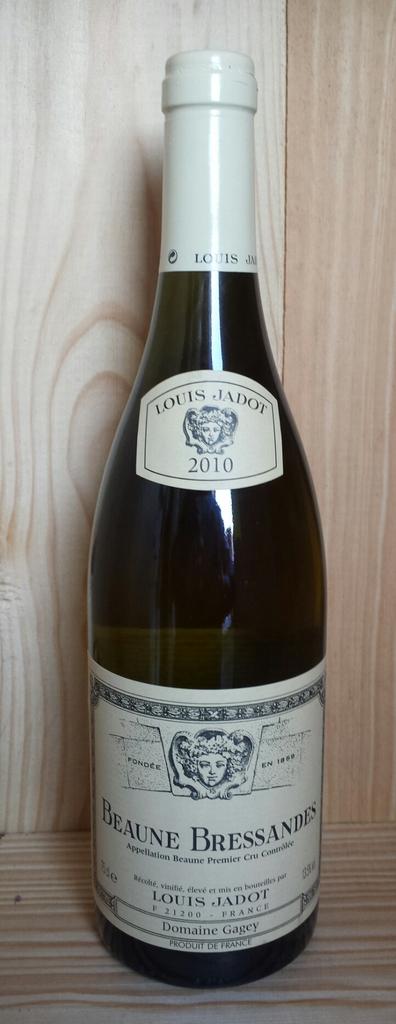Where was this beverage made?
Your answer should be compact. France. How old is the wine?
Ensure brevity in your answer.  2010. 